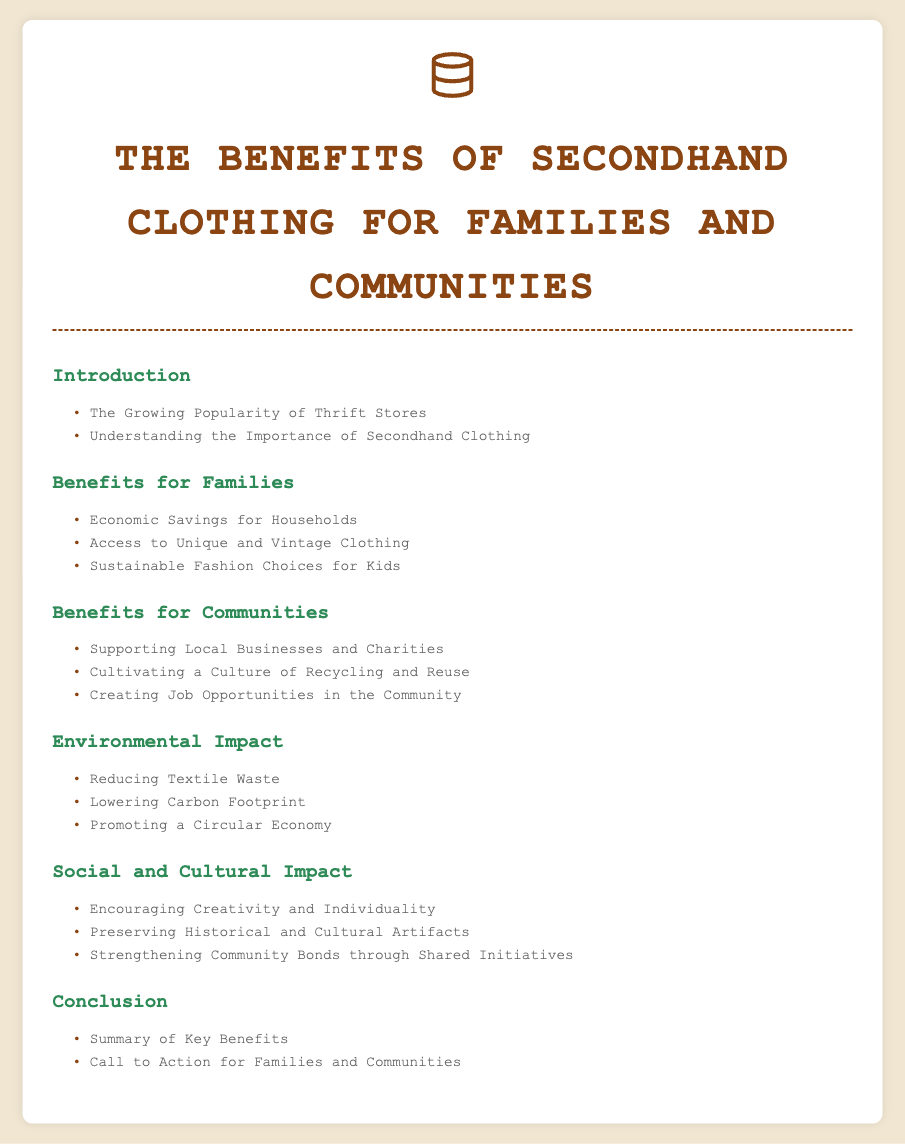What is the first section of the document? The first section is titled "Introduction", which provides an overview of the topic.
Answer: Introduction How many benefits for families are listed? The section "Benefits for Families" includes three subsections detailing economic and lifestyle advantages.
Answer: 3 What unique clothing options does the document mention? The subsection "Access to Unique and Vintage Clothing" notes that secondhand shopping can lead to discovering special items.
Answer: Unique and Vintage Clothing What is one environmental impact of secondhand clothing? The subsection "Reducing Textile Waste" highlights a key environmental benefit of secondhand clothing practices.
Answer: Reducing Textile Waste What cultural impact does thrift shopping encourage? The subsection "Encouraging Creativity and Individuality" suggests that secondhand clothing fosters personal expression through fashion choices.
Answer: Creativity and Individuality Which section discusses local economic support? The section titled "Benefits for Communities" addresses how thrift stores contribute to the local economy.
Answer: Benefits for Communities What is the main call to action mentioned in the conclusion? The subsection "Call to Action for Families and Communities" encourages engagement with local thrift stores and secondhand shopping.
Answer: Call to Action How does secondhand clothing contribute to job creation? The subsection "Creating Job Opportunities in the Community" details how thrift stores can generate employment opportunities.
Answer: Creating Job Opportunities What’s the main theme of the document? The document explores the various advantages of secondhand clothing for both families and communities.
Answer: Advantages of Secondhand Clothing 